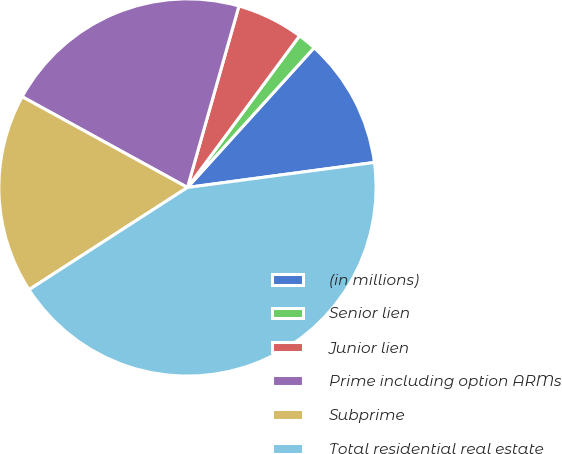<chart> <loc_0><loc_0><loc_500><loc_500><pie_chart><fcel>(in millions)<fcel>Senior lien<fcel>Junior lien<fcel>Prime including option ARMs<fcel>Subprime<fcel>Total residential real estate<nl><fcel>11.16%<fcel>1.59%<fcel>5.73%<fcel>21.41%<fcel>17.11%<fcel>43.0%<nl></chart> 